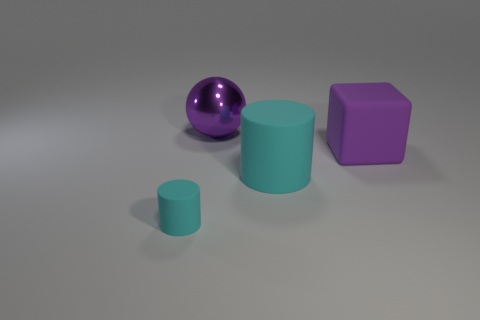Add 4 large spheres. How many objects exist? 8 Subtract all spheres. How many objects are left? 3 Subtract 0 red cylinders. How many objects are left? 4 Subtract all tiny purple cylinders. Subtract all small cyan cylinders. How many objects are left? 3 Add 4 big cyan objects. How many big cyan objects are left? 5 Add 2 purple balls. How many purple balls exist? 3 